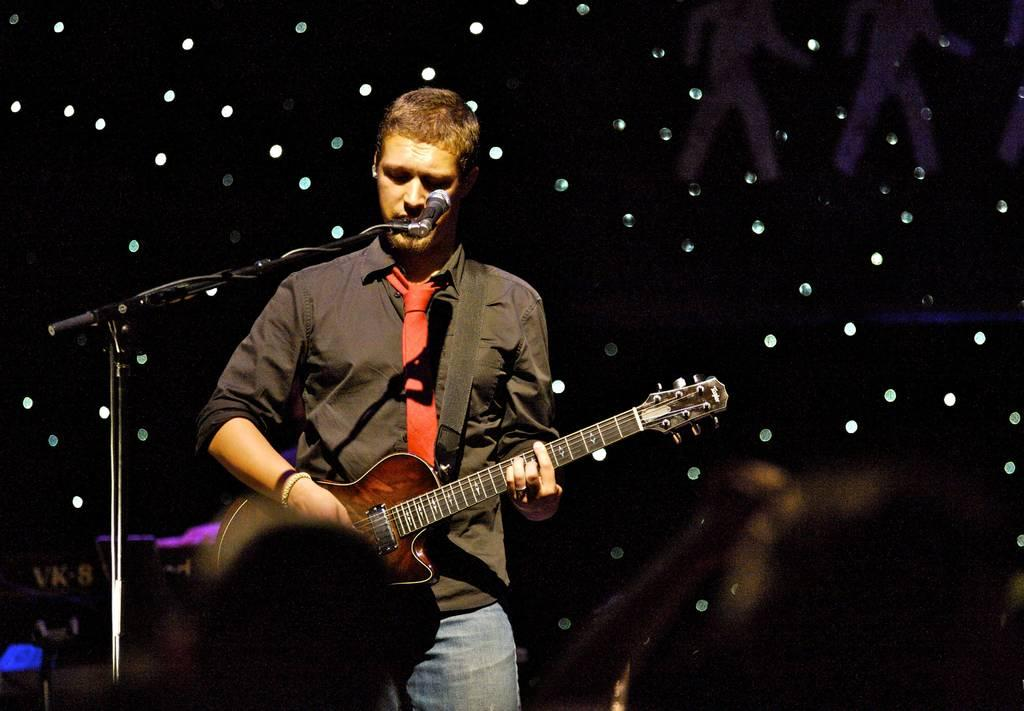What is the man in the image doing? The man is playing a guitar. What object is the man positioned in front of? The man is in front of a microphone. What can be seen in the background of the image? There are lights visible in the background of the image. How many feet are visible on the man's hands in the image? There are no feet visible on the man's hands in the image, as feet are not a part of the human hand. What role does the actor play in the image? There is no actor present in the image, only a man playing a guitar. 